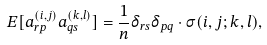Convert formula to latex. <formula><loc_0><loc_0><loc_500><loc_500>E [ a _ { r p } ^ { ( i , j ) } a _ { q s } ^ { ( k , l ) } ] = \frac { 1 } { n } \delta _ { r s } \delta _ { p q } \cdot \sigma ( i , j ; k , l ) ,</formula> 